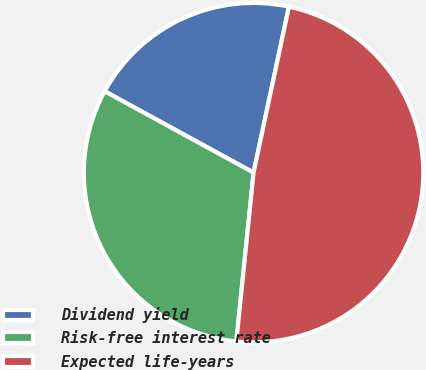Convert chart to OTSL. <chart><loc_0><loc_0><loc_500><loc_500><pie_chart><fcel>Dividend yield<fcel>Risk-free interest rate<fcel>Expected life-years<nl><fcel>20.38%<fcel>31.34%<fcel>48.28%<nl></chart> 